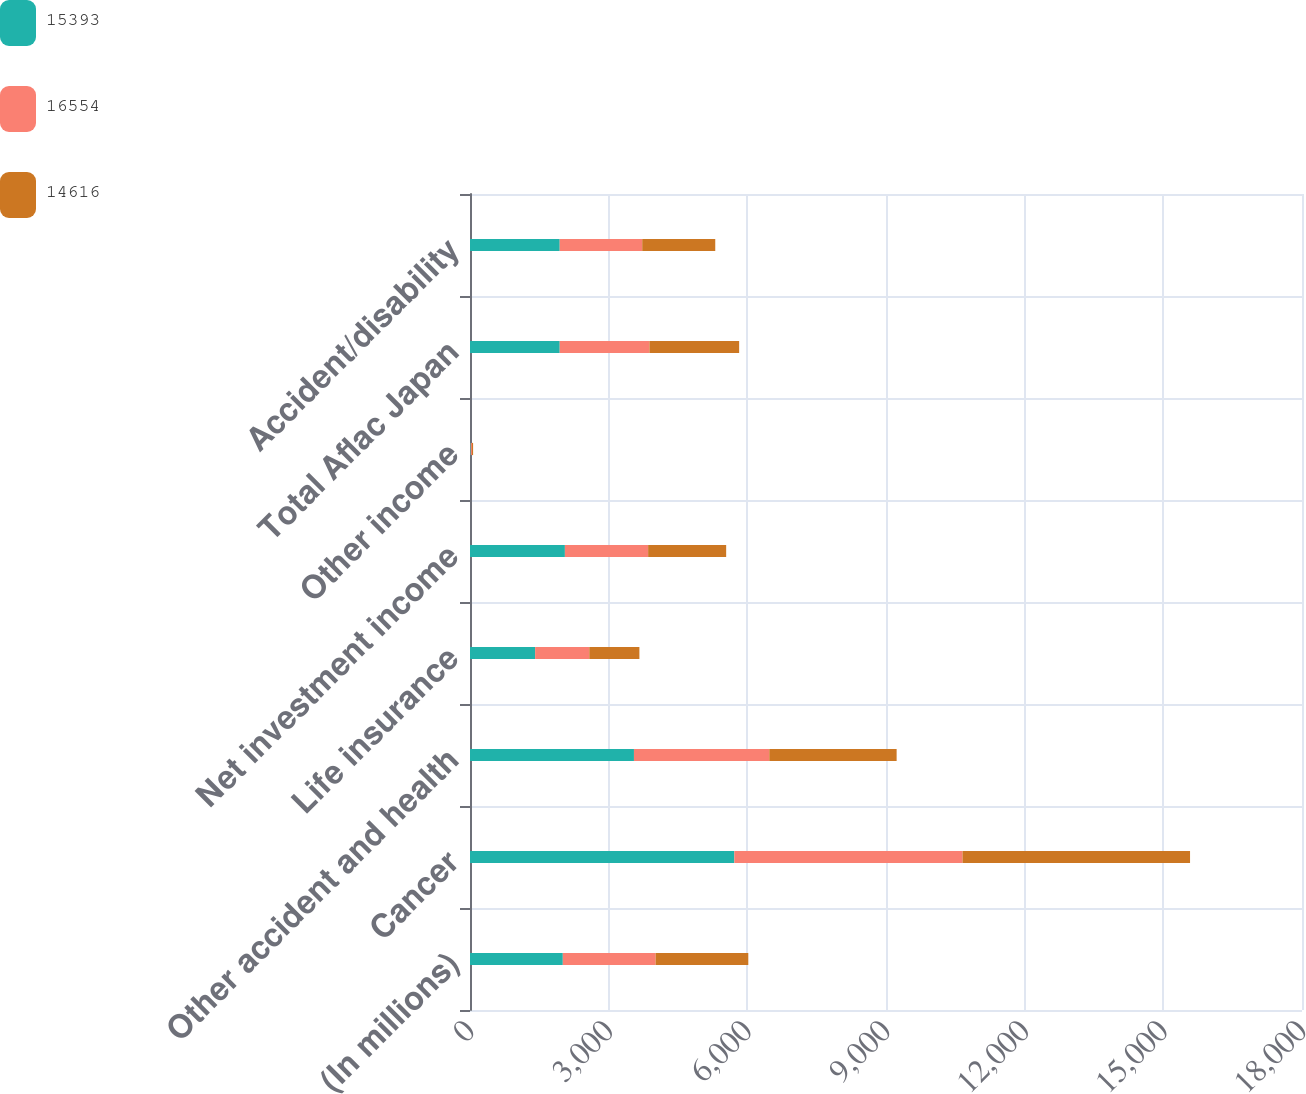<chart> <loc_0><loc_0><loc_500><loc_500><stacked_bar_chart><ecel><fcel>(In millions)<fcel>Cancer<fcel>Other accident and health<fcel>Life insurance<fcel>Net investment income<fcel>Other income<fcel>Total Aflac Japan<fcel>Accident/disability<nl><fcel>15393<fcel>2008<fcel>5718<fcel>3547<fcel>1409<fcel>2053<fcel>15<fcel>1941<fcel>1941<nl><fcel>16554<fcel>2007<fcel>4937<fcel>2928<fcel>1172<fcel>1801<fcel>27<fcel>1941<fcel>1785<nl><fcel>14616<fcel>2006<fcel>4923<fcel>2755<fcel>1084<fcel>1688<fcel>25<fcel>1941<fcel>1580<nl></chart> 